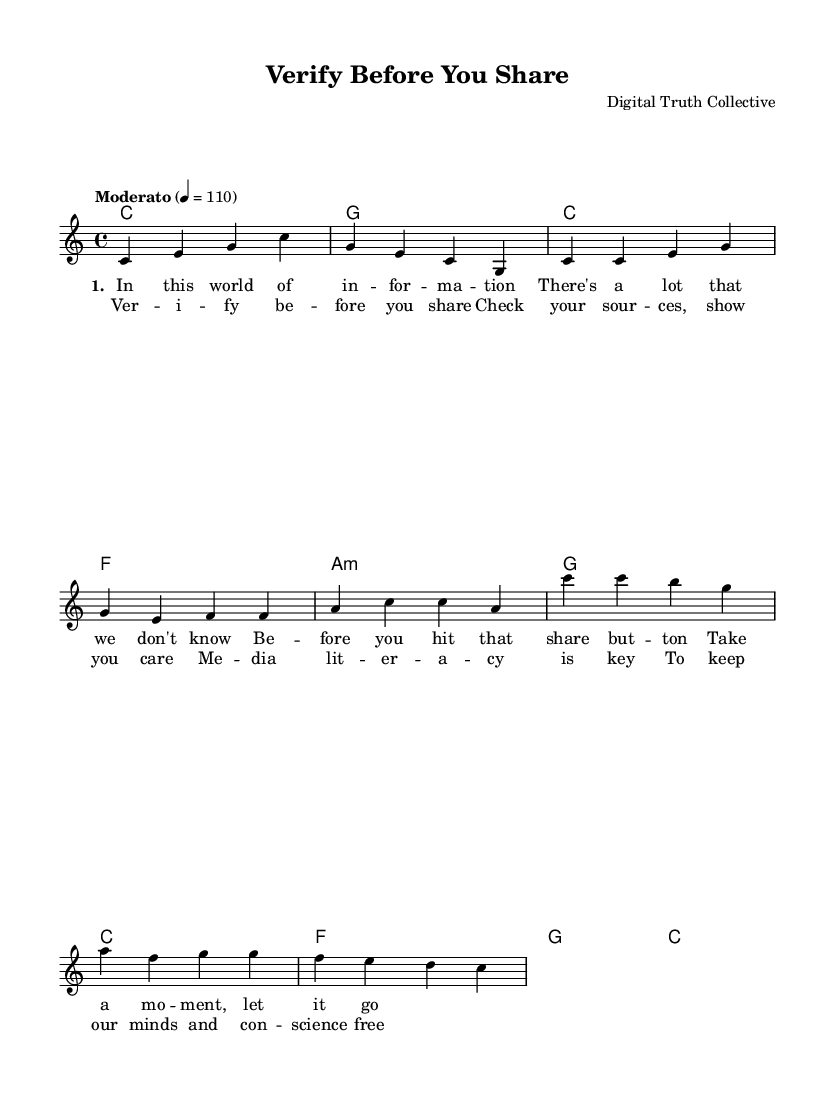What is the key signature of this music? The key signature is indicated at the beginning of the score. It shows that there are no sharps or flats, which corresponds to C major.
Answer: C major What is the time signature of this piece? The time signature, found above the staff, is 4/4, which means there are four beats in each measure, and each quarter note gets one beat.
Answer: 4/4 What is the tempo marking for this song? The tempo is indicated with "Moderato" followed by a metronome marking of 110, meaning a moderately paced tempo at 110 beats per minute.
Answer: Moderato, 110 How many verses are present in the song? By analyzing the structure of the lyrics, there is one verse repeated in the provided lyrics indicating it does not have multiple distinct verses; there's just one.
Answer: 1 What chord follows the "Intro" section? In the chord progression, the intro ends on a G chord, as indicated by the notation shown after the opening measures of the piece.
Answer: G What theme is addressed in the chorus of the song? The chorus contains lyrics focusing on the importance of fact-checking and media literacy, aligning with the theme of caution in sharing information.
Answer: Fact-checking and media literacy 